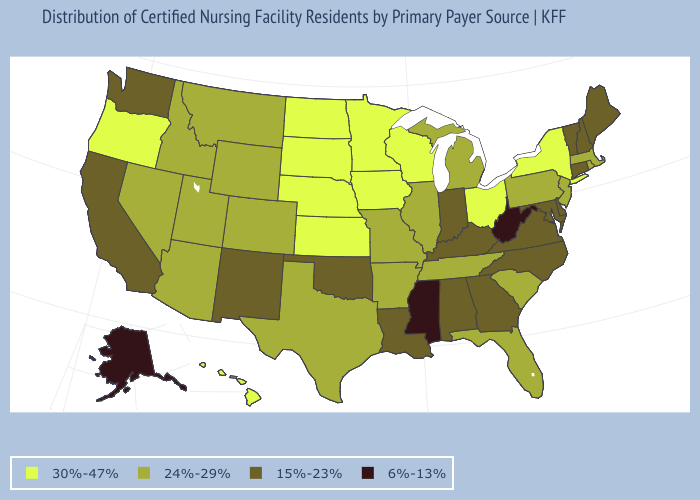Name the states that have a value in the range 15%-23%?
Write a very short answer. Alabama, California, Connecticut, Delaware, Georgia, Indiana, Kentucky, Louisiana, Maine, Maryland, New Hampshire, New Mexico, North Carolina, Oklahoma, Vermont, Virginia, Washington. Does Arkansas have a higher value than New York?
Concise answer only. No. Does Delaware have the same value as Georgia?
Quick response, please. Yes. How many symbols are there in the legend?
Give a very brief answer. 4. What is the value of North Dakota?
Be succinct. 30%-47%. Is the legend a continuous bar?
Quick response, please. No. What is the highest value in states that border Delaware?
Quick response, please. 24%-29%. What is the value of Illinois?
Concise answer only. 24%-29%. What is the value of Michigan?
Give a very brief answer. 24%-29%. What is the value of Massachusetts?
Write a very short answer. 24%-29%. What is the lowest value in states that border Utah?
Quick response, please. 15%-23%. Name the states that have a value in the range 15%-23%?
Keep it brief. Alabama, California, Connecticut, Delaware, Georgia, Indiana, Kentucky, Louisiana, Maine, Maryland, New Hampshire, New Mexico, North Carolina, Oklahoma, Vermont, Virginia, Washington. What is the value of Missouri?
Write a very short answer. 24%-29%. What is the value of Illinois?
Give a very brief answer. 24%-29%. Which states hav the highest value in the South?
Concise answer only. Arkansas, Florida, South Carolina, Tennessee, Texas. 